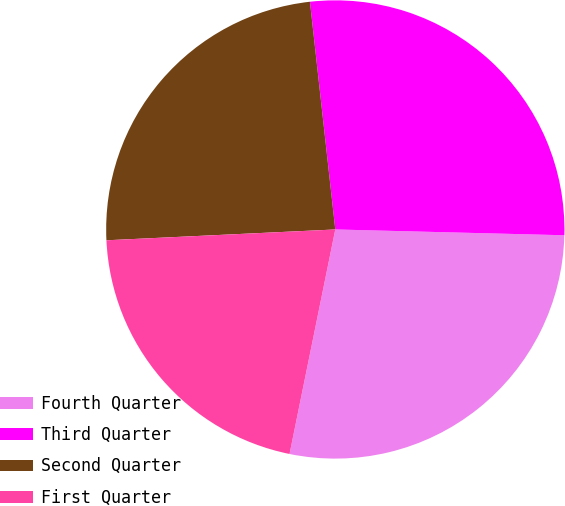Convert chart. <chart><loc_0><loc_0><loc_500><loc_500><pie_chart><fcel>Fourth Quarter<fcel>Third Quarter<fcel>Second Quarter<fcel>First Quarter<nl><fcel>27.8%<fcel>27.17%<fcel>23.99%<fcel>21.05%<nl></chart> 